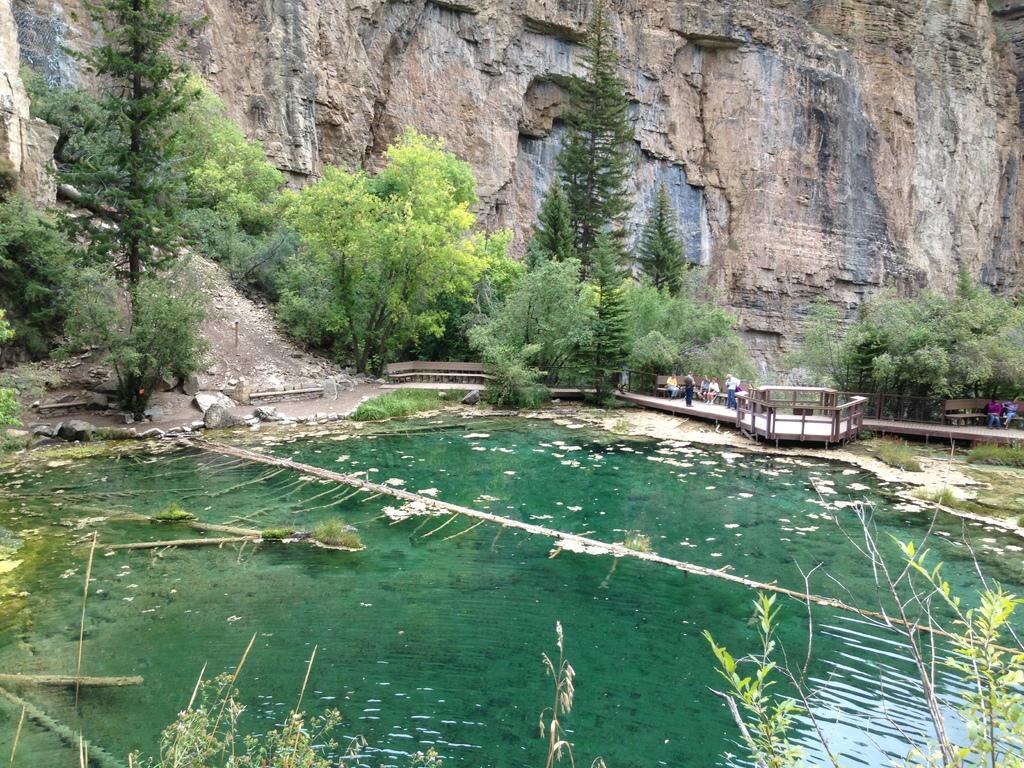Describe this image in one or two sentences. In this image at the bottom, there are plants and water. In the middle there are trees, people, benches, land and hill. 